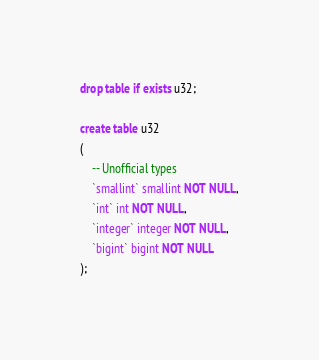<code> <loc_0><loc_0><loc_500><loc_500><_SQL_>drop table if exists u32;

create table u32
(
    -- Unofficial types
    `smallint` smallint NOT NULL,
    `int` int NOT NULL,
    `integer` integer NOT NULL,
    `bigint` bigint NOT NULL
);
</code> 